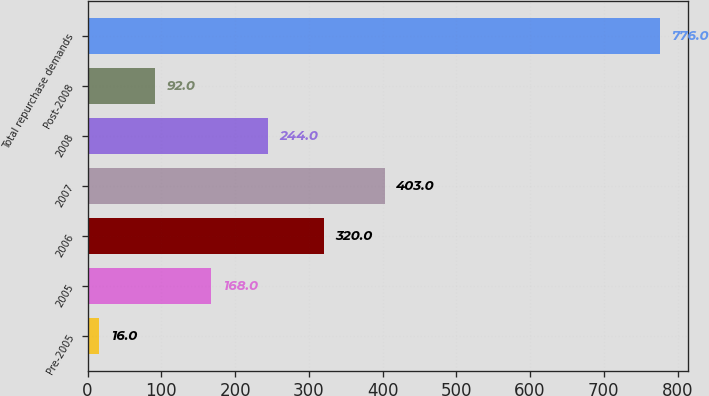Convert chart. <chart><loc_0><loc_0><loc_500><loc_500><bar_chart><fcel>Pre-2005<fcel>2005<fcel>2006<fcel>2007<fcel>2008<fcel>Post-2008<fcel>Total repurchase demands<nl><fcel>16<fcel>168<fcel>320<fcel>403<fcel>244<fcel>92<fcel>776<nl></chart> 